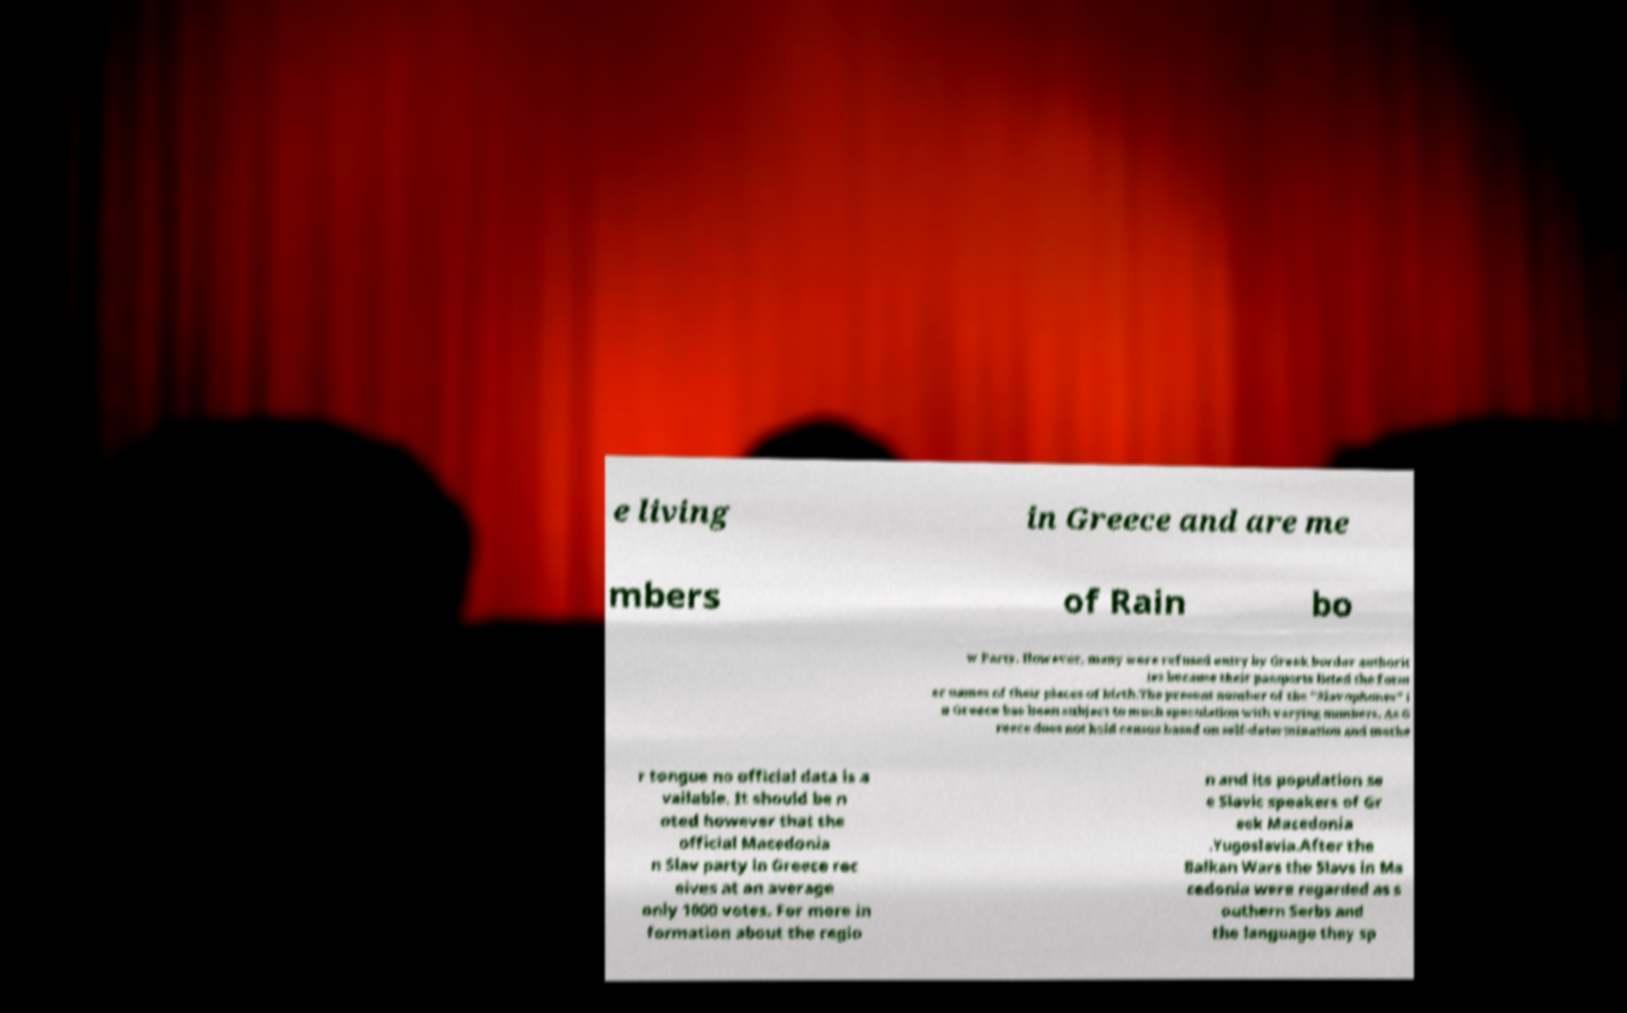Could you assist in decoding the text presented in this image and type it out clearly? e living in Greece and are me mbers of Rain bo w Party. However, many were refused entry by Greek border authorit ies because their passports listed the form er names of their places of birth.The present number of the "Slavophones" i n Greece has been subject to much speculation with varying numbers. As G reece does not hold census based on self-determination and mothe r tongue no official data is a vailable. It should be n oted however that the official Macedonia n Slav party in Greece rec eives at an average only 1000 votes. For more in formation about the regio n and its population se e Slavic speakers of Gr eek Macedonia .Yugoslavia.After the Balkan Wars the Slavs in Ma cedonia were regarded as s outhern Serbs and the language they sp 